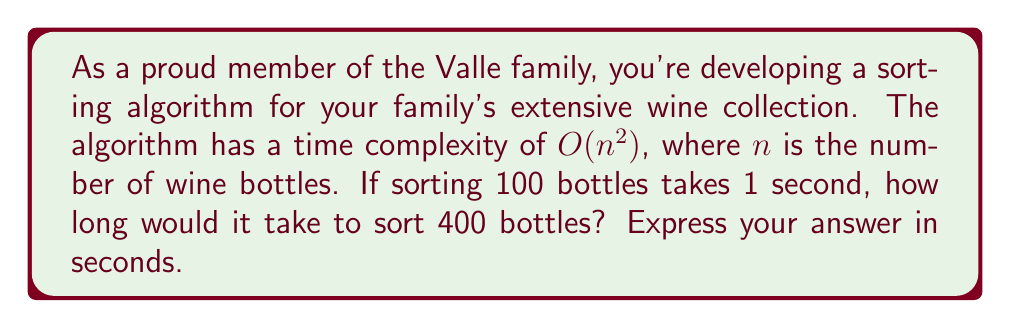Provide a solution to this math problem. Let's approach this step-by-step:

1) The algorithm has a time complexity of $O(n^2)$. This means that the runtime is proportional to the square of the input size.

2) Let's define a constant $c$ such that the runtime $T(n) = cn^2$ for some input size $n$.

3) We're given that for $n = 100$, $T(100) = 1$ second. Let's use this to find $c$:

   $1 = c(100)^2$
   $1 = 10000c$
   $c = \frac{1}{10000} = 10^{-4}$

4) Now that we know $c$, we can use it to find the time for $n = 400$:

   $T(400) = 10^{-4} * (400)^2$
           $= 10^{-4} * 160000$
           $= 16$ seconds

5) We can verify this result by comparing the ratio of the input sizes squared:

   $(\frac{400}{100})^2 = 4^2 = 16$

   This confirms that the runtime for 400 bottles should be 16 times the runtime for 100 bottles.
Answer: 16 seconds 